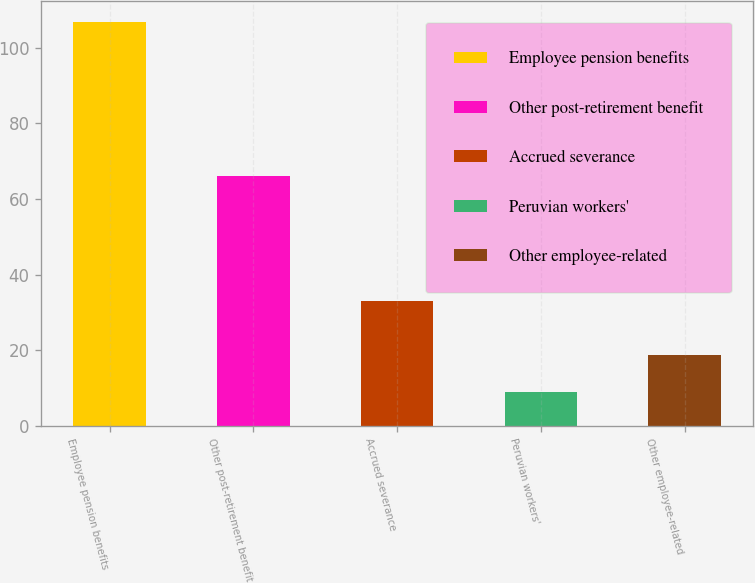Convert chart. <chart><loc_0><loc_0><loc_500><loc_500><bar_chart><fcel>Employee pension benefits<fcel>Other post-retirement benefit<fcel>Accrued severance<fcel>Peruvian workers'<fcel>Other employee-related<nl><fcel>107<fcel>66<fcel>33<fcel>9<fcel>18.8<nl></chart> 